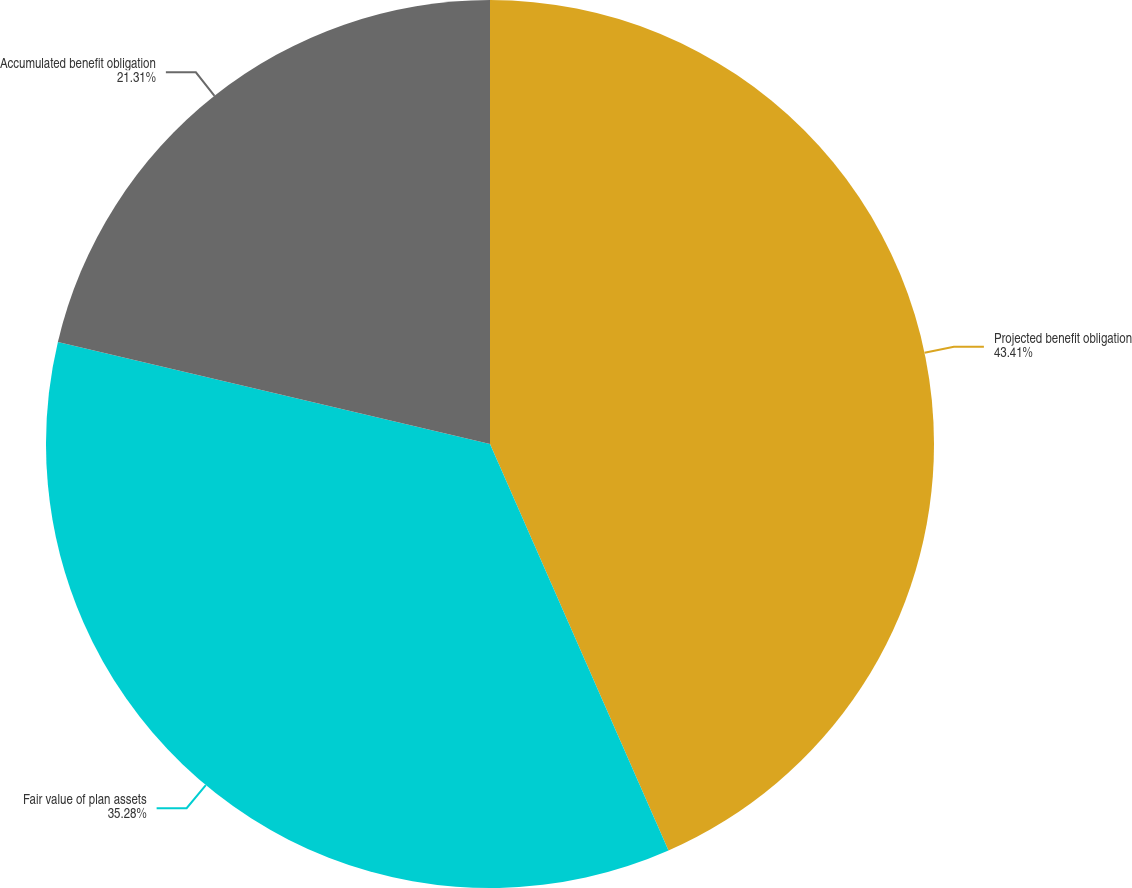<chart> <loc_0><loc_0><loc_500><loc_500><pie_chart><fcel>Projected benefit obligation<fcel>Fair value of plan assets<fcel>Accumulated benefit obligation<nl><fcel>43.42%<fcel>35.28%<fcel>21.31%<nl></chart> 